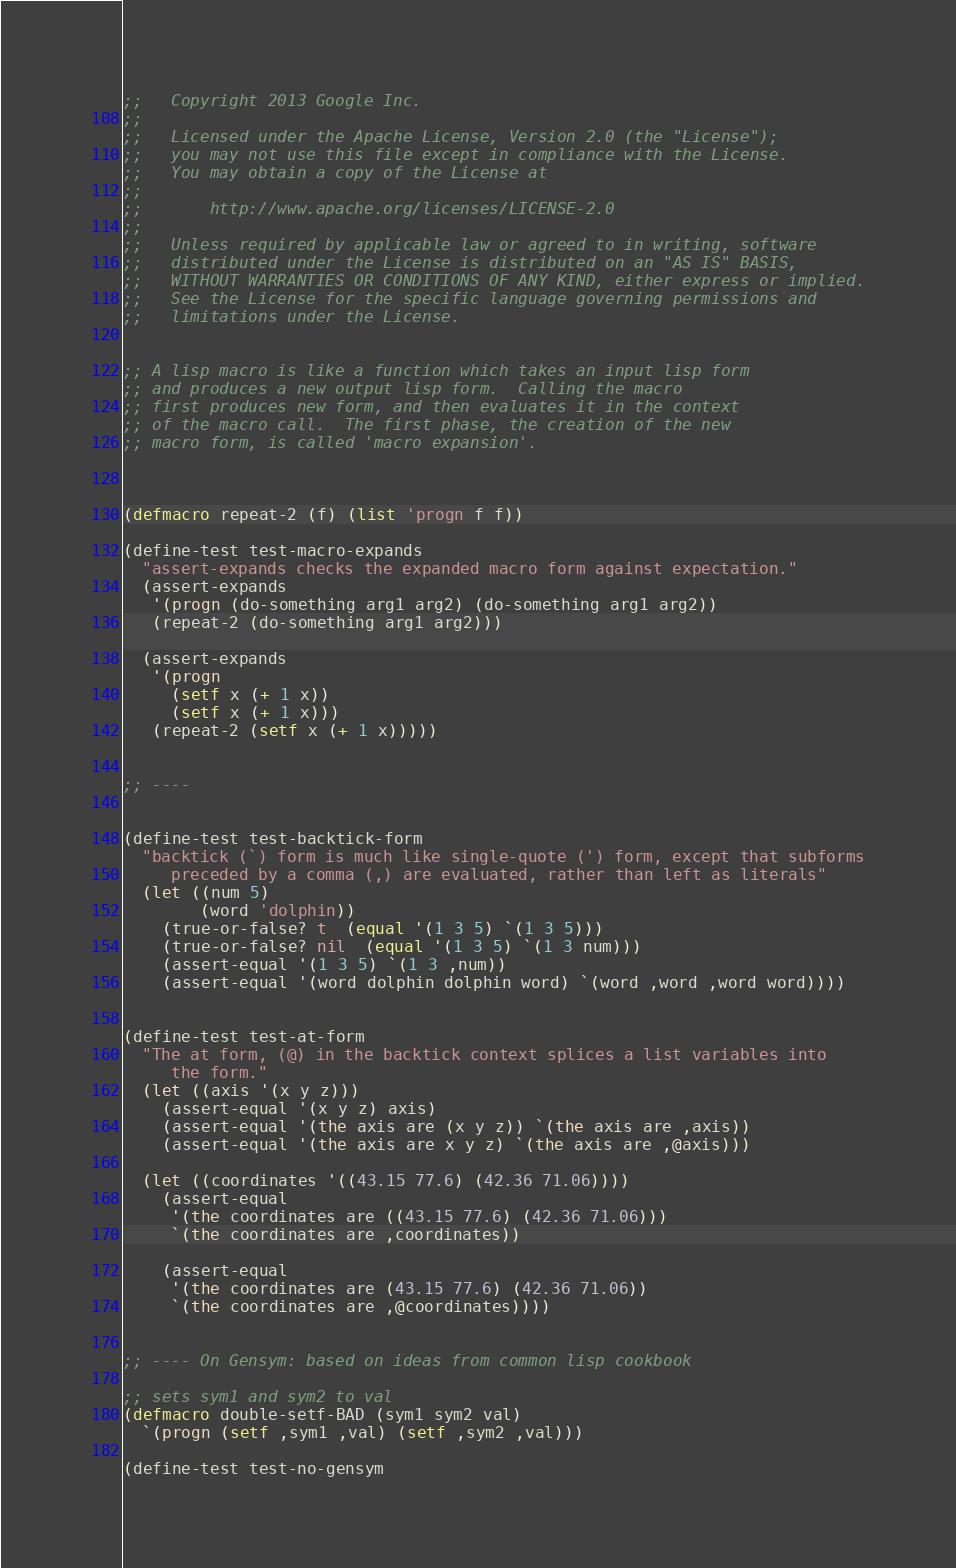Convert code to text. <code><loc_0><loc_0><loc_500><loc_500><_Lisp_>;;   Copyright 2013 Google Inc.
;;
;;   Licensed under the Apache License, Version 2.0 (the "License");
;;   you may not use this file except in compliance with the License.
;;   You may obtain a copy of the License at
;;
;;       http://www.apache.org/licenses/LICENSE-2.0
;;
;;   Unless required by applicable law or agreed to in writing, software
;;   distributed under the License is distributed on an "AS IS" BASIS,
;;   WITHOUT WARRANTIES OR CONDITIONS OF ANY KIND, either express or implied.
;;   See the License for the specific language governing permissions and
;;   limitations under the License.


;; A lisp macro is like a function which takes an input lisp form
;; and produces a new output lisp form.  Calling the macro
;; first produces new form, and then evaluates it in the context
;; of the macro call.  The first phase, the creation of the new
;; macro form, is called 'macro expansion'.



(defmacro repeat-2 (f) (list 'progn f f))

(define-test test-macro-expands
  "assert-expands checks the expanded macro form against expectation."
  (assert-expands
   '(progn (do-something arg1 arg2) (do-something arg1 arg2))
   (repeat-2 (do-something arg1 arg2)))

  (assert-expands
   '(progn
     (setf x (+ 1 x))
     (setf x (+ 1 x)))
   (repeat-2 (setf x (+ 1 x)))))


;; ----


(define-test test-backtick-form
  "backtick (`) form is much like single-quote (') form, except that subforms
     preceded by a comma (,) are evaluated, rather than left as literals"
  (let ((num 5)
        (word 'dolphin))
    (true-or-false? t  (equal '(1 3 5) `(1 3 5)))
    (true-or-false? nil  (equal '(1 3 5) `(1 3 num)))
    (assert-equal '(1 3 5) `(1 3 ,num))
    (assert-equal '(word dolphin dolphin word) `(word ,word ,word word))))


(define-test test-at-form
  "The at form, (@) in the backtick context splices a list variables into
     the form."
  (let ((axis '(x y z)))
    (assert-equal '(x y z) axis)
    (assert-equal '(the axis are (x y z)) `(the axis are ,axis))
    (assert-equal '(the axis are x y z) `(the axis are ,@axis)))

  (let ((coordinates '((43.15 77.6) (42.36 71.06))))
    (assert-equal
     '(the coordinates are ((43.15 77.6) (42.36 71.06)))
     `(the coordinates are ,coordinates))

    (assert-equal
     '(the coordinates are (43.15 77.6) (42.36 71.06))
     `(the coordinates are ,@coordinates))))


;; ---- On Gensym: based on ideas from common lisp cookbook

;; sets sym1 and sym2 to val
(defmacro double-setf-BAD (sym1 sym2 val)
  `(progn (setf ,sym1 ,val) (setf ,sym2 ,val)))

(define-test test-no-gensym</code> 